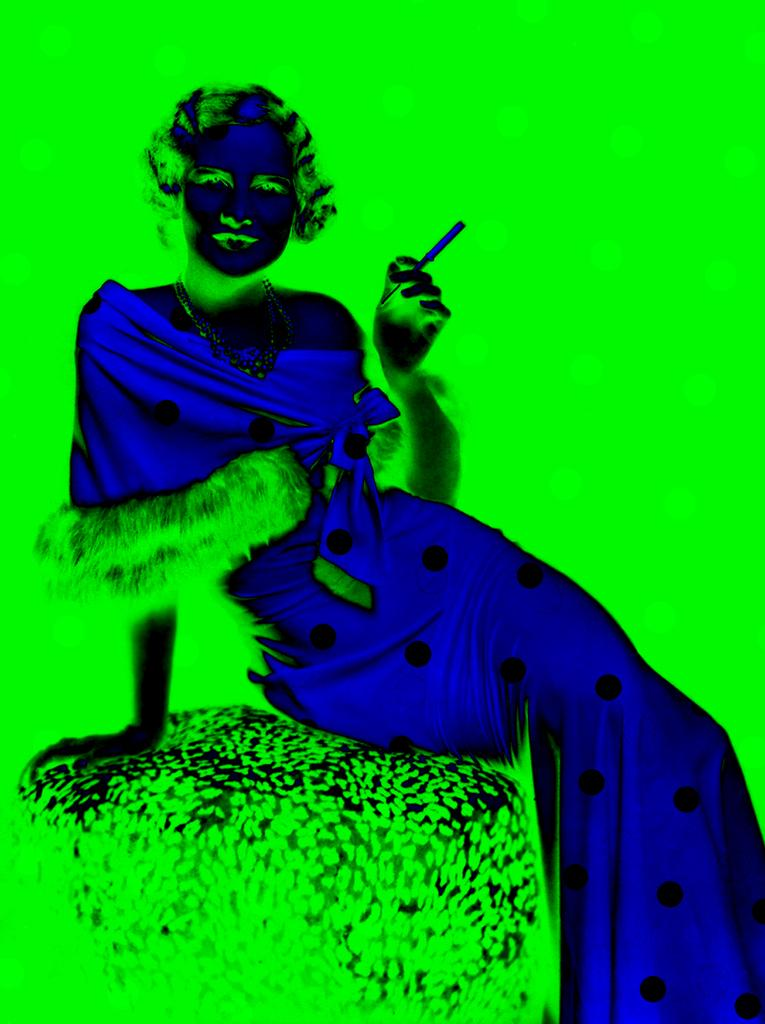What is the main subject of the image? There is a person in the image. What is the person wearing? The person is wearing a dress. What is the person holding in the image? The person is holding something. What is the person sitting on in the image? The person is sitting on an object. What color is the background of the image? The background of the image is green. How many fingers can be seen on the person's hand in the image? There is no information about the person's fingers in the provided facts, so we cannot determine the number of fingers visible in the image. 